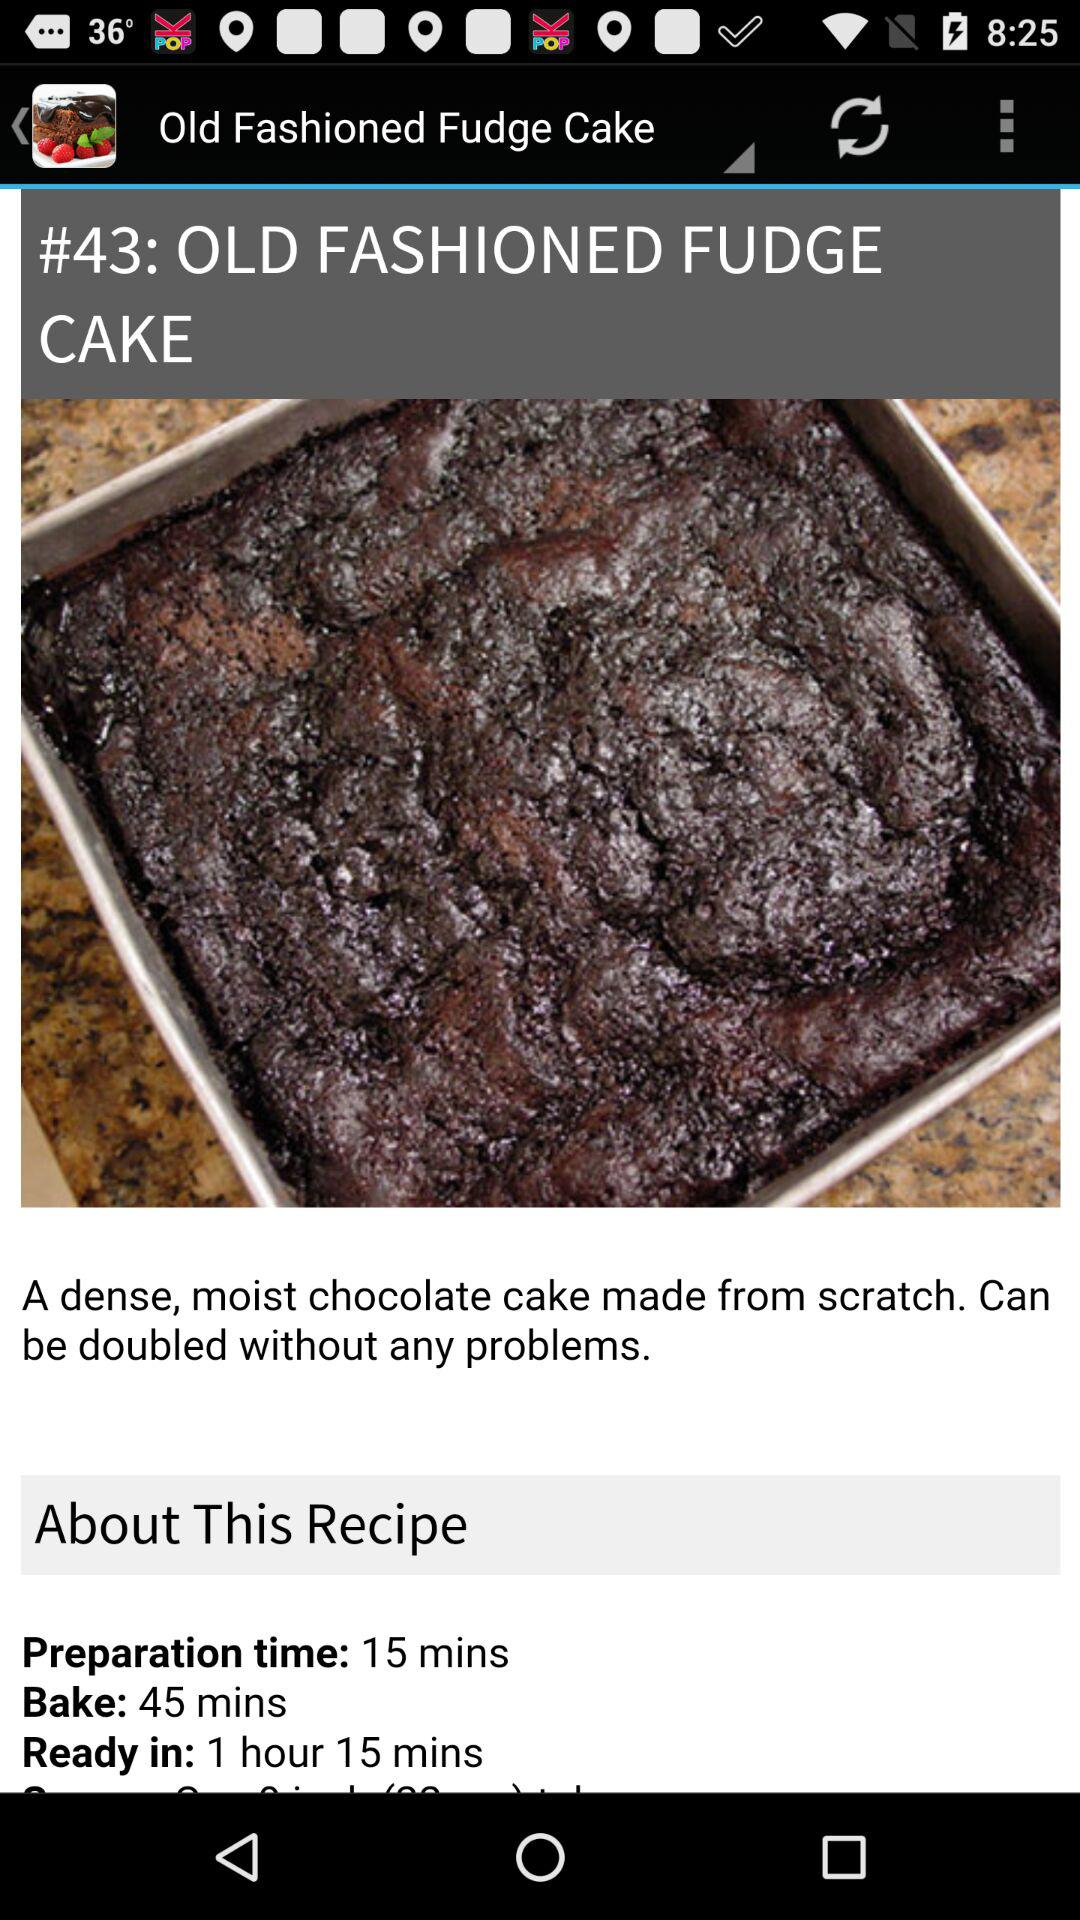What is the bake time for "OLD FASHIONED FUDGE CAKE"? The bake time is 45 minutes. 